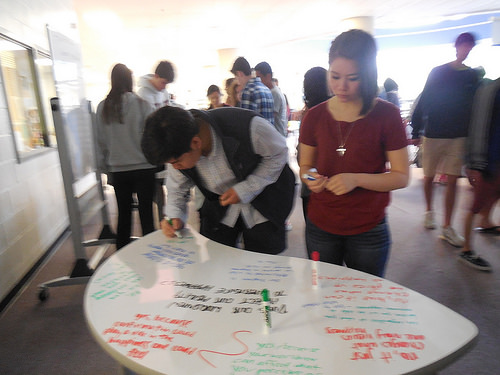<image>
Is there a woman behind the table? Yes. From this viewpoint, the woman is positioned behind the table, with the table partially or fully occluding the woman. Is there a marker in front of the girl? Yes. The marker is positioned in front of the girl, appearing closer to the camera viewpoint. 